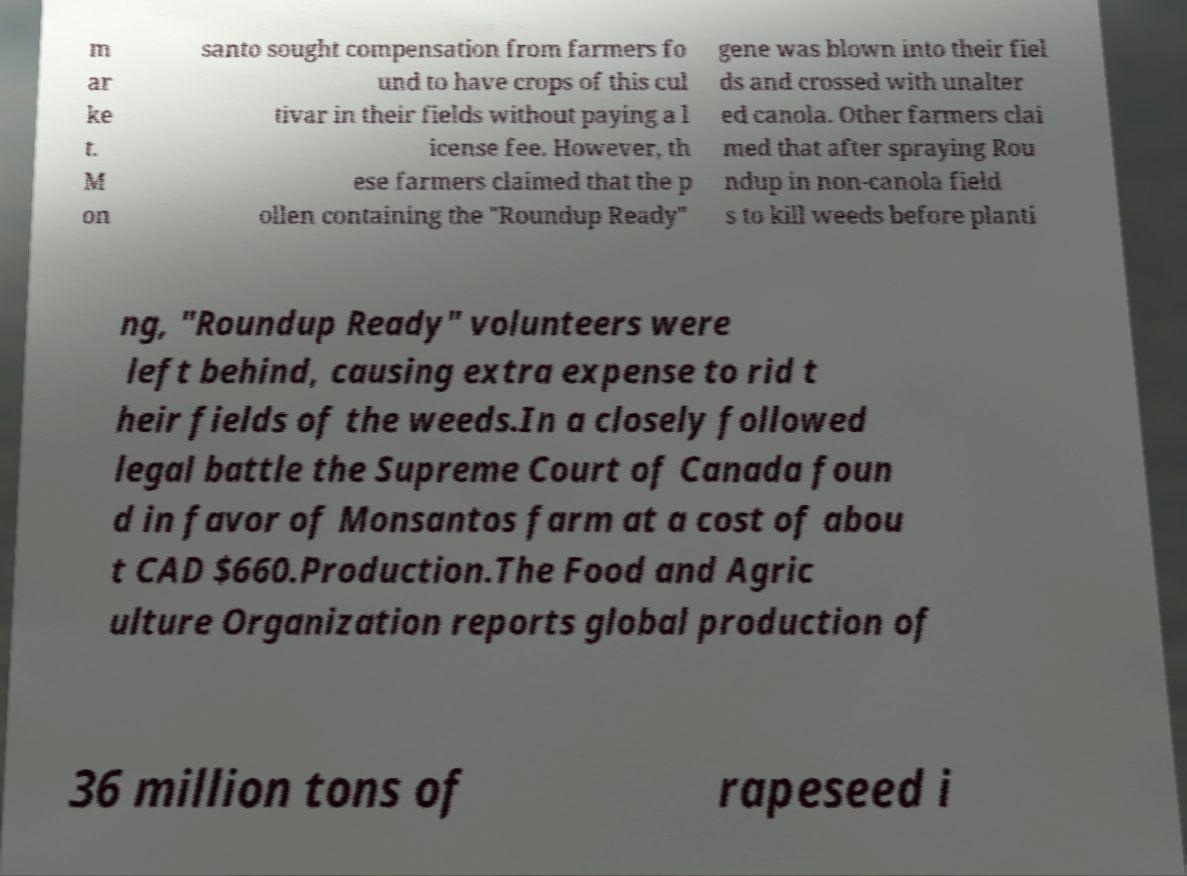There's text embedded in this image that I need extracted. Can you transcribe it verbatim? m ar ke t. M on santo sought compensation from farmers fo und to have crops of this cul tivar in their fields without paying a l icense fee. However, th ese farmers claimed that the p ollen containing the "Roundup Ready" gene was blown into their fiel ds and crossed with unalter ed canola. Other farmers clai med that after spraying Rou ndup in non-canola field s to kill weeds before planti ng, "Roundup Ready" volunteers were left behind, causing extra expense to rid t heir fields of the weeds.In a closely followed legal battle the Supreme Court of Canada foun d in favor of Monsantos farm at a cost of abou t CAD $660.Production.The Food and Agric ulture Organization reports global production of 36 million tons of rapeseed i 